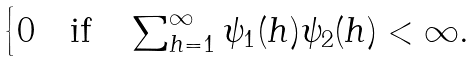Convert formula to latex. <formula><loc_0><loc_0><loc_500><loc_500>\begin{cases} 0 \text {\quad if\quad} \sum _ { h = 1 } ^ { \infty } \psi _ { 1 } ( h ) \psi _ { 2 } ( h ) < \infty . \end{cases}</formula> 